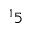Convert formula to latex. <formula><loc_0><loc_0><loc_500><loc_500>^ { 1 } 5</formula> 